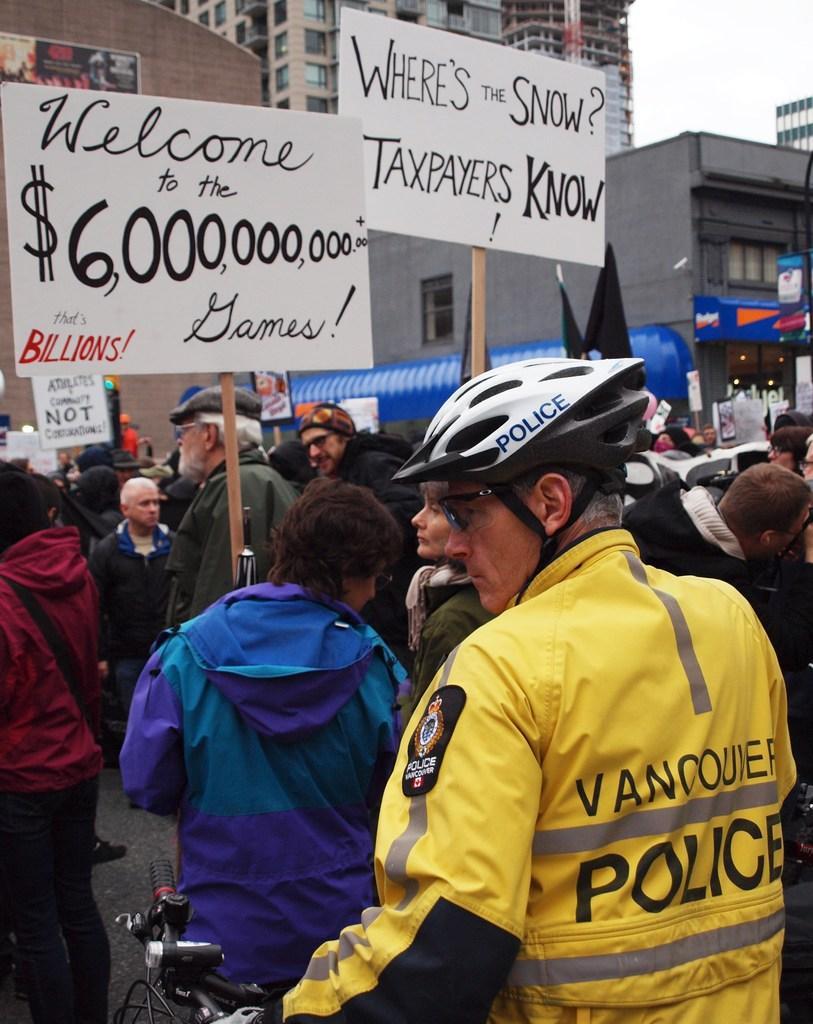In one or two sentences, can you explain what this image depicts? In front of the image there is a police with a bicycle, in front of the police there are a few protesters holding placards in their hands in front of them there are buildings. 